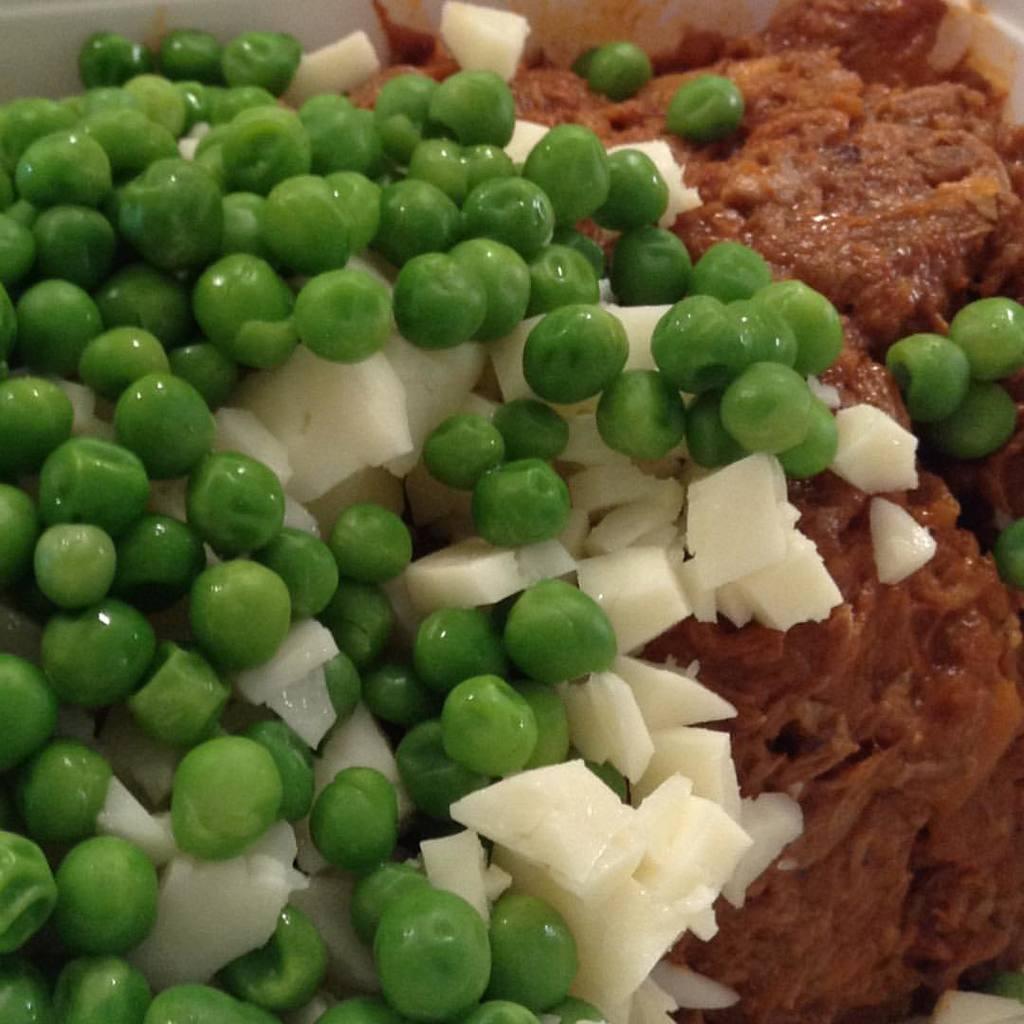Please provide a concise description of this image. In the image there are green peas and other food items. 